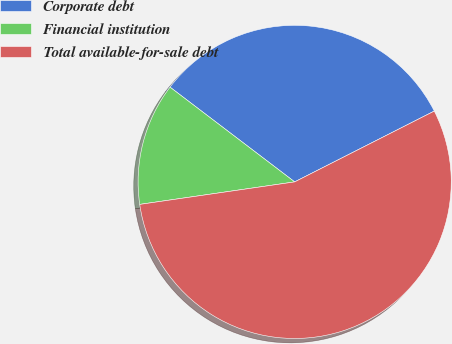Convert chart to OTSL. <chart><loc_0><loc_0><loc_500><loc_500><pie_chart><fcel>Corporate debt<fcel>Financial institution<fcel>Total available-for-sale debt<nl><fcel>32.18%<fcel>12.64%<fcel>55.17%<nl></chart> 